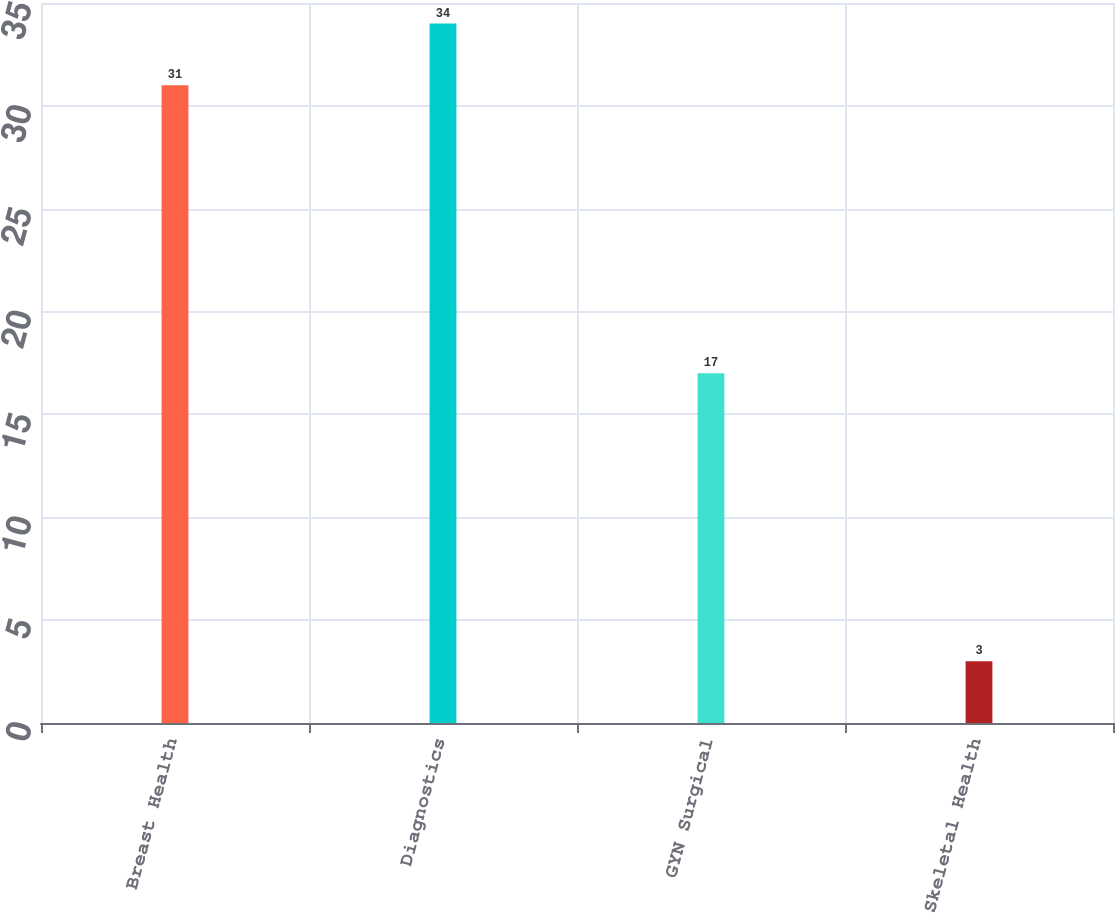Convert chart to OTSL. <chart><loc_0><loc_0><loc_500><loc_500><bar_chart><fcel>Breast Health<fcel>Diagnostics<fcel>GYN Surgical<fcel>Skeletal Health<nl><fcel>31<fcel>34<fcel>17<fcel>3<nl></chart> 